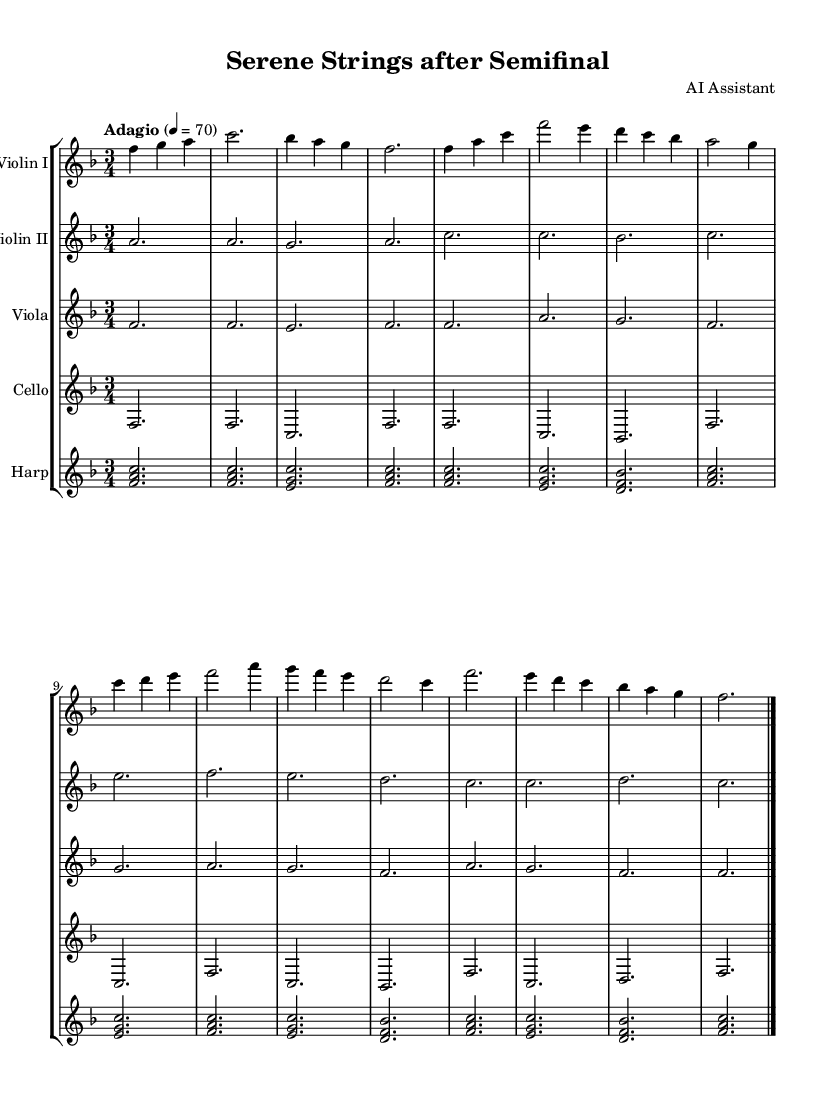What is the key signature of this music? The key signature is F major, indicated by the presence of one flat (B♭). This can be identified at the beginning of the sheet music.
Answer: F major What is the time signature of this music? The time signature is 3/4, which means there are three beats in each measure and a quarter note receives one beat. You can find this stated clearly in the initial part of the music sheet.
Answer: 3/4 What is the tempo marking for this piece? The tempo marking is "Adagio," which indicates a slow and relaxed pace. This is specified in the score shortly after the time signature.
Answer: Adagio What instrument is playing the melody in the introduction? The melody in the introduction is played by Violin I, as it contains the main notes that move through the musical phrases, while the other instruments provide accompaniment.
Answer: Violin I How many measures are in the Coda section? The Coda section consists of 4 measures, which can be identified from the final part of the music score leading up to the double bar at the end. Counting the measures gives you this total.
Answer: 4 Which instrument plays the simplified bass line? The instrument playing the simplified bass line is the cello, which is indicated by its specific staff and the notes that typically play the lower pitches in the arrangement.
Answer: Cello What kind of musical pattern does the harp use throughout? The harp utilizes arpeggios throughout the piece, evident from the broken chords that are spread out over the measures, creating a flowing sound. This can be seen in the notes assigned to the harp part in the sheet music.
Answer: Arpeggios 